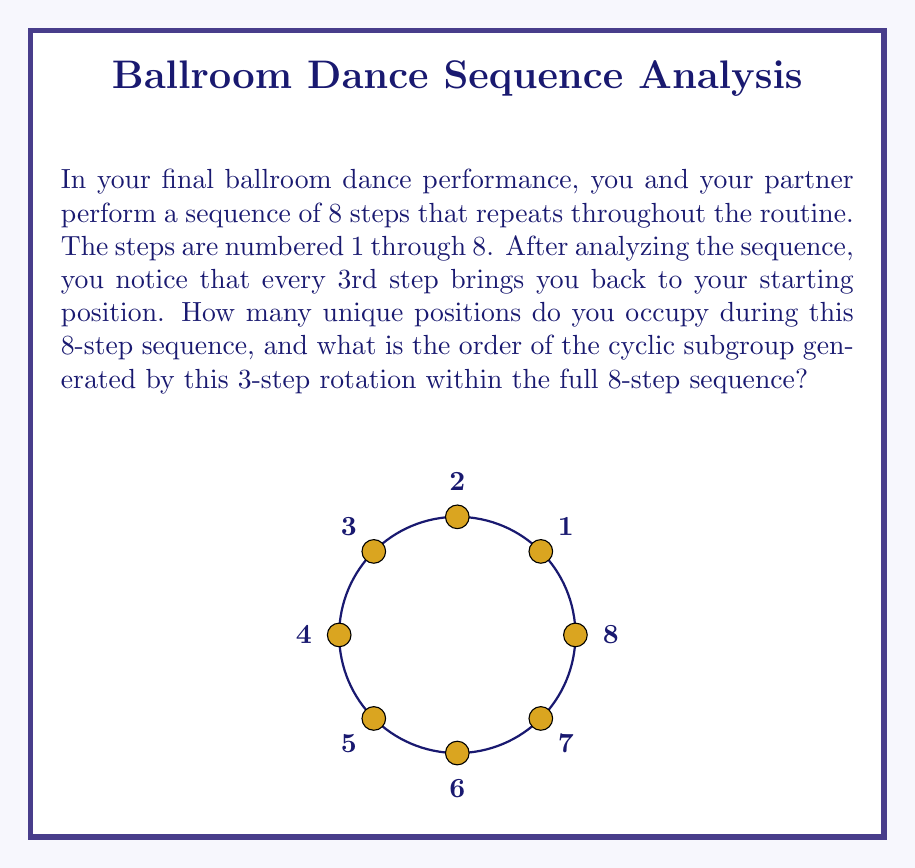What is the answer to this math problem? Let's approach this step-by-step:

1) First, we need to understand what the question is asking. We have an 8-step sequence, but every 3rd step brings us back to the starting position.

2) To find the unique positions, let's see where each 3-step rotation takes us:
   Starting at 1: 1 → 4 → 7 → 2 → 5 → 8 → 3 → 6 → 1

3) We can see that this rotation generates 3 unique positions: {1, 4, 7}, {2, 5, 8}, and {3, 6}.

4) Therefore, there are 3 unique positions occupied during the 8-step sequence.

5) Now, for the order of the cyclic subgroup: In group theory, the order of an element is the smallest positive integer $n$ such that $a^n = e$ (the identity element).

6) In this case, we're looking at the 3-step rotation. Let's call this rotation $r$. We want to find the smallest $n$ such that $r^n = e$.

7) We can see that:
   $r^1$ takes us from 1 to 4
   $r^2$ takes us from 1 to 7
   $r^3$ takes us from 1 to 2
   $r^4$ takes us from 1 to 5
   $r^5$ takes us from 1 to 8
   $r^6$ takes us from 1 to 3
   $r^7$ takes us from 1 to 6
   $r^8$ takes us back to 1

8) Therefore, the order of the cyclic subgroup generated by this 3-step rotation is 8.

9) In mathematical notation, we can write this as: $\langle r \rangle = \{e, r, r^2, ..., r^7\}$, where $e$ is the identity element (no rotation).
Answer: 3 unique positions; order 8 